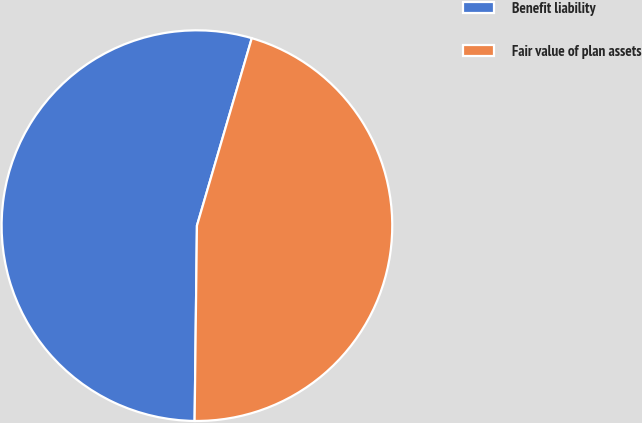Convert chart. <chart><loc_0><loc_0><loc_500><loc_500><pie_chart><fcel>Benefit liability<fcel>Fair value of plan assets<nl><fcel>54.34%<fcel>45.66%<nl></chart> 